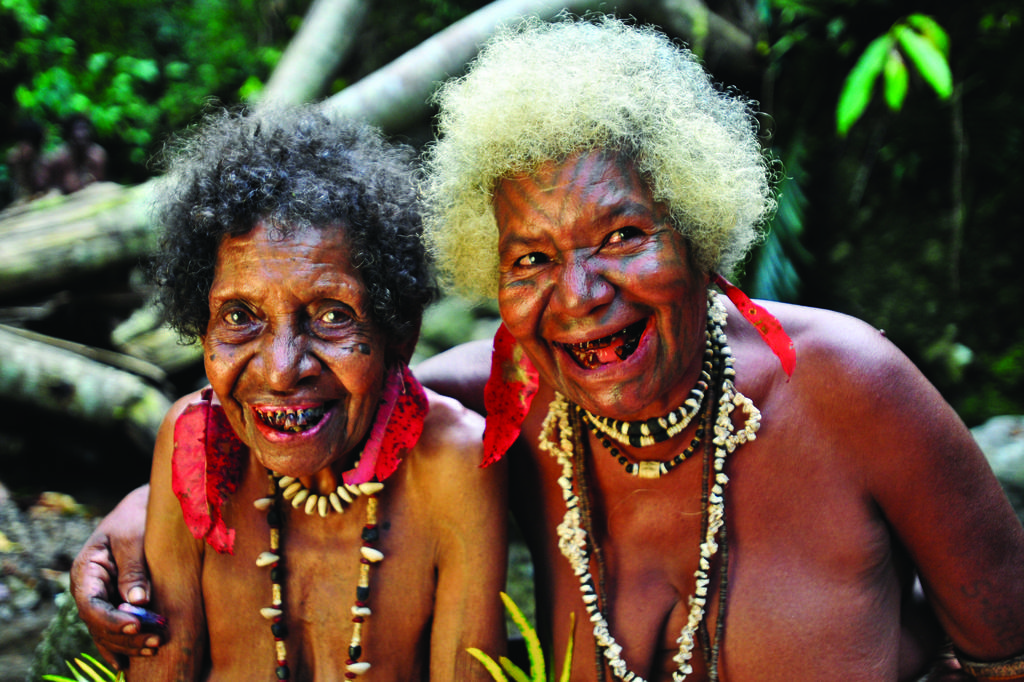How many people are in the image? There are two persons in the image. What can be seen in the background of the image? There are trees in the background of the image. What is the color of the trees in the image? The trees are green in color. What type of balloon is being used by the persons in the image? There is no balloon present in the image. What hobbies do the persons in the image share? The provided facts do not give any information about the hobbies of the persons in the image. What type of vessel can be seen in the image? There is no vessel present in the image. 